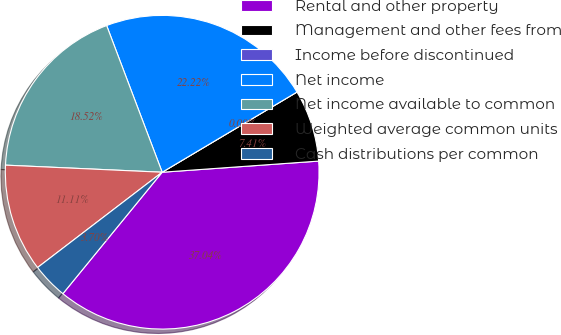<chart> <loc_0><loc_0><loc_500><loc_500><pie_chart><fcel>Rental and other property<fcel>Management and other fees from<fcel>Income before discontinued<fcel>Net income<fcel>Net income available to common<fcel>Weighted average common units<fcel>Cash distributions per common<nl><fcel>37.04%<fcel>7.41%<fcel>0.0%<fcel>22.22%<fcel>18.52%<fcel>11.11%<fcel>3.7%<nl></chart> 